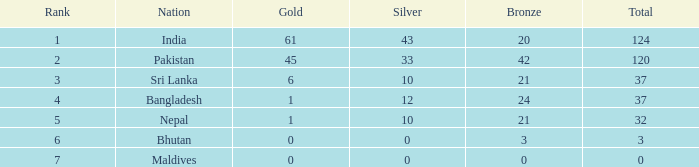For a bronze of 21 and a silver more than 10, what is their rank? 0.0. 